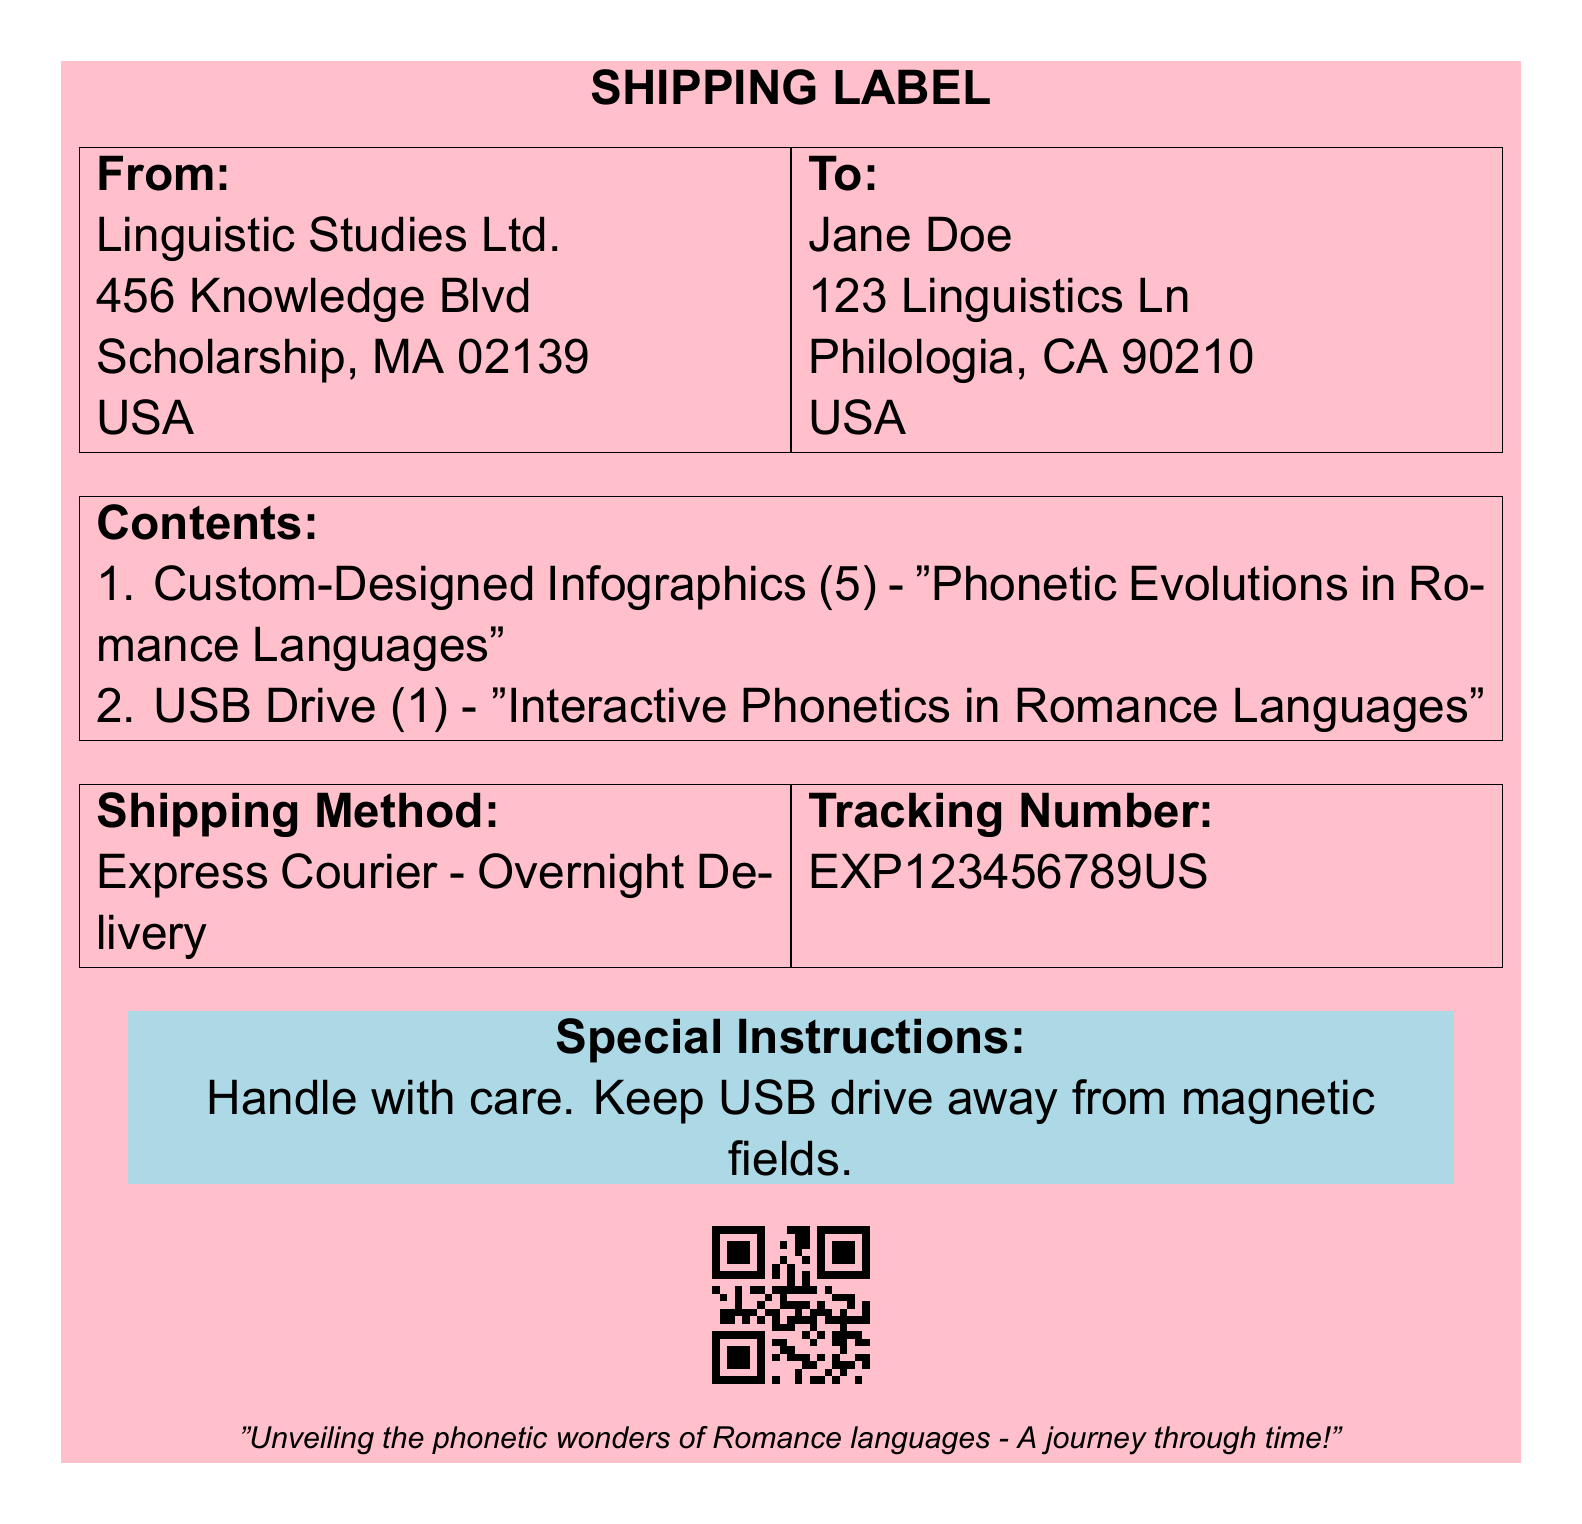What is the sender's name? The sender is listed in the "From" section of the label, which indicates Linguistic Studies Ltd.
Answer: Linguistic Studies Ltd How many custom-designed infographics are included? The contents section specifies there are 5 custom-designed infographics.
Answer: 5 What is the shipping method used? The shipping method is mentioned in the relevant section as "Express Courier - Overnight Delivery."
Answer: Express Courier - Overnight Delivery What is the destination city for the shipment? The destination address shows the city as Philologia, which is in CA.
Answer: Philologia What should be avoided to protect the USB drive? The special instructions highlight the need to keep the USB drive away from magnetic fields.
Answer: Magnetic fields How many items are listed in total? There are two types of items listed in the contents section: custom-designed infographics and a USB drive.
Answer: 2 What tracking number is associated with this shipment? The tracking number is provided in the relevant section as EXP123456789US.
Answer: EXP123456789US What color is used for the special instructions box? The color of the special instructions box is identified as phonetics blue in the document.
Answer: Phonetics blue 